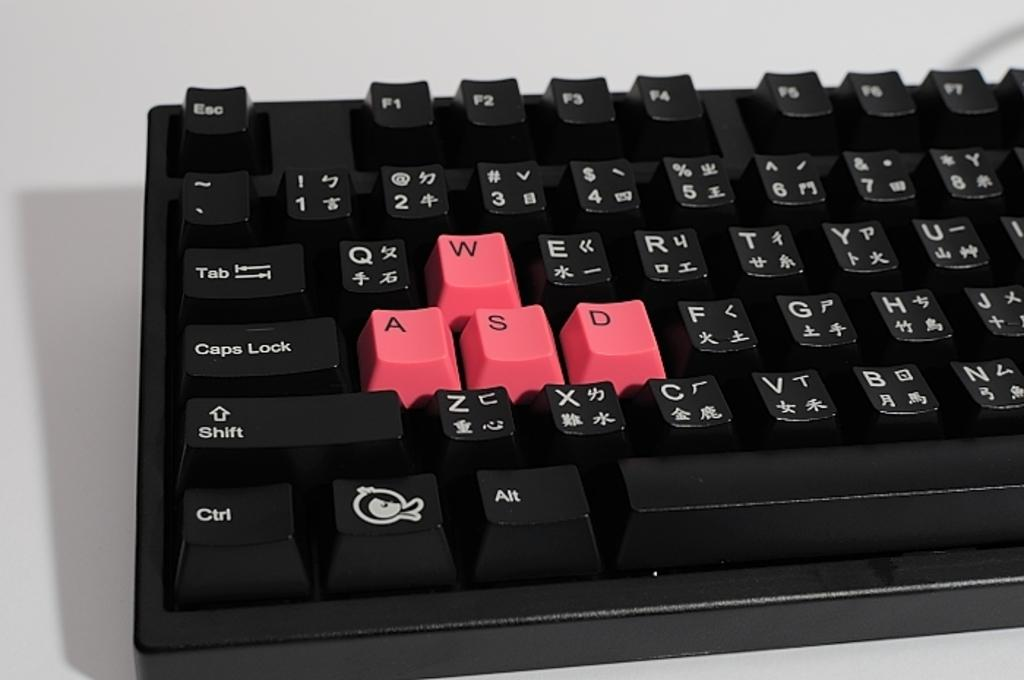<image>
Render a clear and concise summary of the photo. Computer keyboard that has red keys of w, a, s, and d 